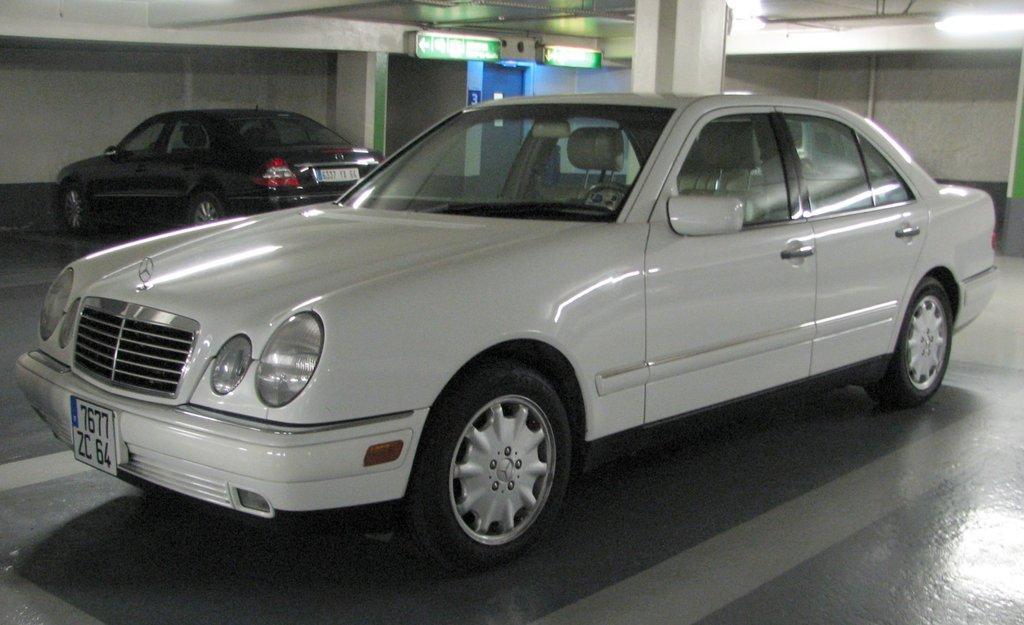Could you give a brief overview of what you see in this image? As we can see in the image there are two cars, wall and lights. the car in the front is in white color car and the other is in black color. 